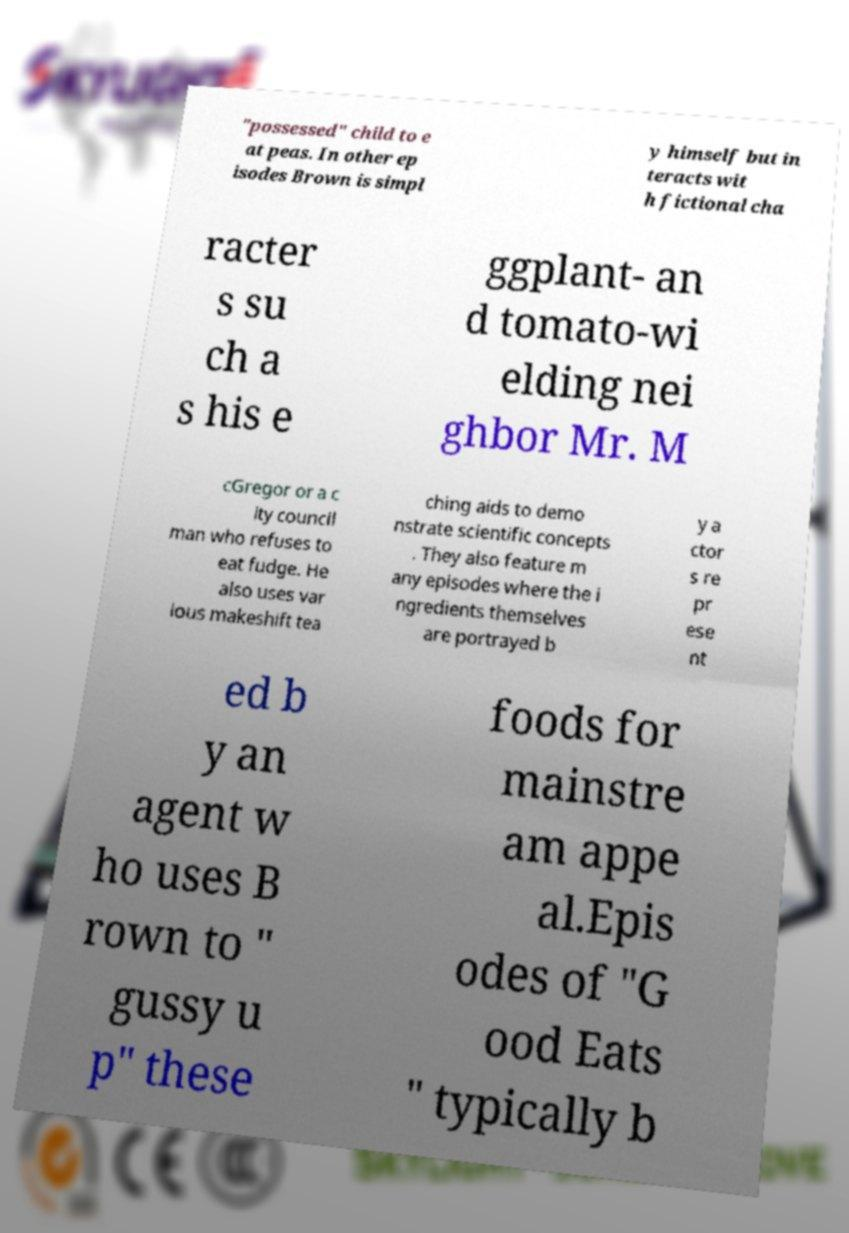Could you extract and type out the text from this image? "possessed" child to e at peas. In other ep isodes Brown is simpl y himself but in teracts wit h fictional cha racter s su ch a s his e ggplant- an d tomato-wi elding nei ghbor Mr. M cGregor or a c ity council man who refuses to eat fudge. He also uses var ious makeshift tea ching aids to demo nstrate scientific concepts . They also feature m any episodes where the i ngredients themselves are portrayed b y a ctor s re pr ese nt ed b y an agent w ho uses B rown to " gussy u p" these foods for mainstre am appe al.Epis odes of "G ood Eats " typically b 